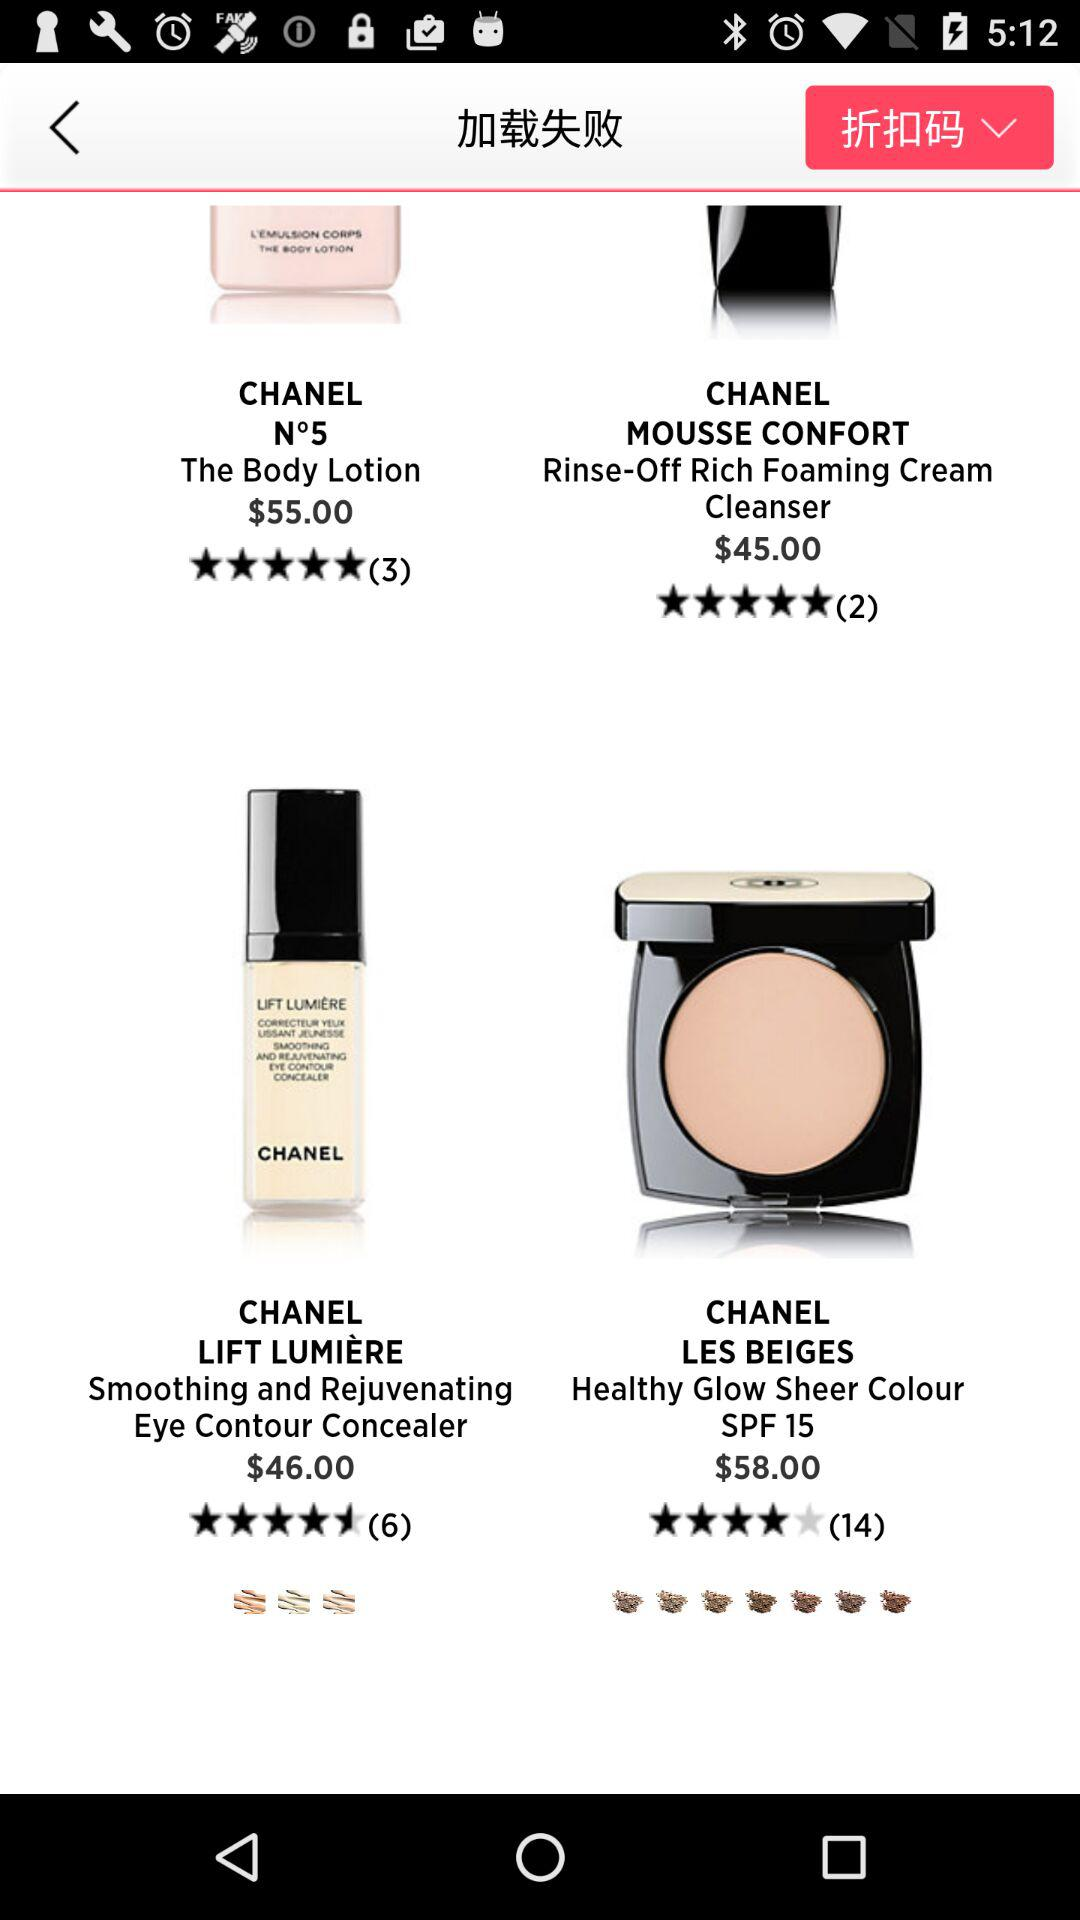What is the exact rating of "Chanel Lift Lumiere"? The exact rating is 4.5 stars. 